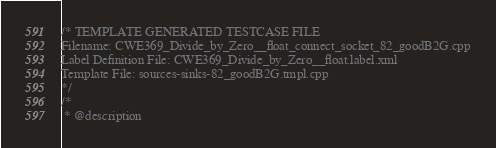Convert code to text. <code><loc_0><loc_0><loc_500><loc_500><_C++_>/* TEMPLATE GENERATED TESTCASE FILE
Filename: CWE369_Divide_by_Zero__float_connect_socket_82_goodB2G.cpp
Label Definition File: CWE369_Divide_by_Zero__float.label.xml
Template File: sources-sinks-82_goodB2G.tmpl.cpp
*/
/*
 * @description</code> 